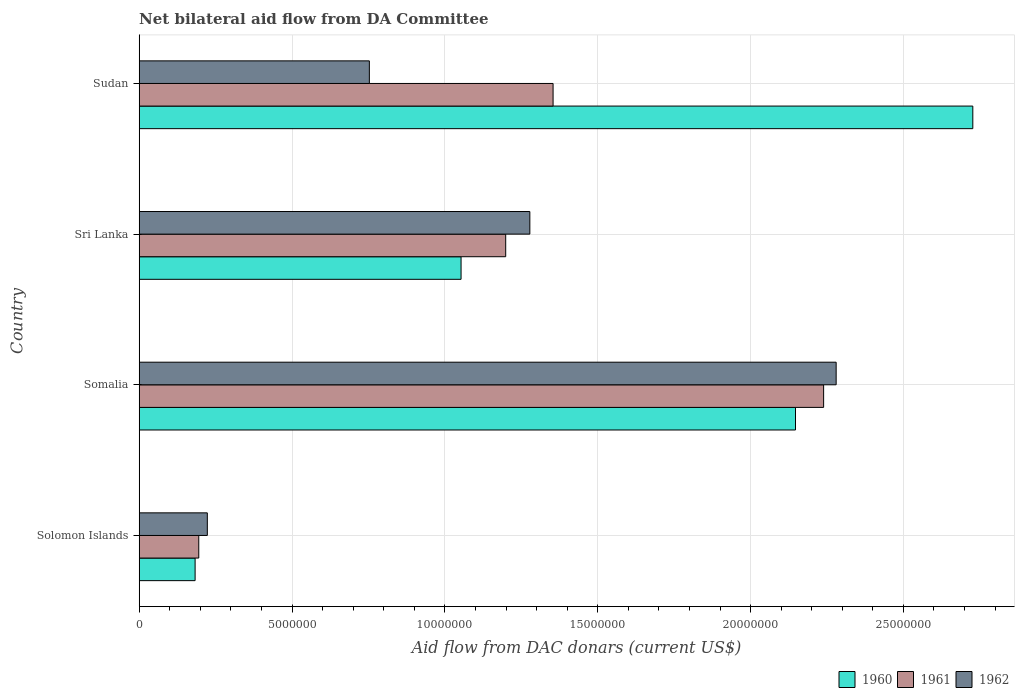Are the number of bars on each tick of the Y-axis equal?
Provide a short and direct response. Yes. How many bars are there on the 4th tick from the bottom?
Your response must be concise. 3. What is the label of the 1st group of bars from the top?
Your answer should be very brief. Sudan. In how many cases, is the number of bars for a given country not equal to the number of legend labels?
Provide a short and direct response. 0. What is the aid flow in in 1962 in Somalia?
Keep it short and to the point. 2.28e+07. Across all countries, what is the maximum aid flow in in 1961?
Provide a short and direct response. 2.24e+07. Across all countries, what is the minimum aid flow in in 1961?
Your answer should be very brief. 1.95e+06. In which country was the aid flow in in 1960 maximum?
Your answer should be very brief. Sudan. In which country was the aid flow in in 1962 minimum?
Make the answer very short. Solomon Islands. What is the total aid flow in in 1960 in the graph?
Ensure brevity in your answer.  6.11e+07. What is the difference between the aid flow in in 1960 in Solomon Islands and that in Sri Lanka?
Keep it short and to the point. -8.70e+06. What is the difference between the aid flow in in 1962 in Solomon Islands and the aid flow in in 1960 in Somalia?
Ensure brevity in your answer.  -1.92e+07. What is the average aid flow in in 1962 per country?
Keep it short and to the point. 1.13e+07. In how many countries, is the aid flow in in 1961 greater than 18000000 US$?
Ensure brevity in your answer.  1. What is the ratio of the aid flow in in 1961 in Solomon Islands to that in Somalia?
Keep it short and to the point. 0.09. Is the aid flow in in 1960 in Solomon Islands less than that in Sudan?
Give a very brief answer. Yes. Is the difference between the aid flow in in 1960 in Somalia and Sri Lanka greater than the difference between the aid flow in in 1961 in Somalia and Sri Lanka?
Your response must be concise. Yes. What is the difference between the highest and the second highest aid flow in in 1960?
Provide a succinct answer. 5.80e+06. What is the difference between the highest and the lowest aid flow in in 1960?
Your answer should be compact. 2.54e+07. Is the sum of the aid flow in in 1962 in Somalia and Sri Lanka greater than the maximum aid flow in in 1960 across all countries?
Offer a terse response. Yes. Are all the bars in the graph horizontal?
Offer a terse response. Yes. How many countries are there in the graph?
Make the answer very short. 4. What is the difference between two consecutive major ticks on the X-axis?
Provide a succinct answer. 5.00e+06. Are the values on the major ticks of X-axis written in scientific E-notation?
Provide a short and direct response. No. Does the graph contain any zero values?
Provide a short and direct response. No. Does the graph contain grids?
Provide a short and direct response. Yes. Where does the legend appear in the graph?
Your answer should be compact. Bottom right. How many legend labels are there?
Make the answer very short. 3. What is the title of the graph?
Give a very brief answer. Net bilateral aid flow from DA Committee. Does "2004" appear as one of the legend labels in the graph?
Give a very brief answer. No. What is the label or title of the X-axis?
Make the answer very short. Aid flow from DAC donars (current US$). What is the label or title of the Y-axis?
Keep it short and to the point. Country. What is the Aid flow from DAC donars (current US$) of 1960 in Solomon Islands?
Your answer should be very brief. 1.83e+06. What is the Aid flow from DAC donars (current US$) of 1961 in Solomon Islands?
Provide a succinct answer. 1.95e+06. What is the Aid flow from DAC donars (current US$) in 1962 in Solomon Islands?
Your answer should be very brief. 2.23e+06. What is the Aid flow from DAC donars (current US$) in 1960 in Somalia?
Your response must be concise. 2.15e+07. What is the Aid flow from DAC donars (current US$) of 1961 in Somalia?
Provide a succinct answer. 2.24e+07. What is the Aid flow from DAC donars (current US$) in 1962 in Somalia?
Offer a terse response. 2.28e+07. What is the Aid flow from DAC donars (current US$) of 1960 in Sri Lanka?
Offer a terse response. 1.05e+07. What is the Aid flow from DAC donars (current US$) of 1961 in Sri Lanka?
Make the answer very short. 1.20e+07. What is the Aid flow from DAC donars (current US$) of 1962 in Sri Lanka?
Your response must be concise. 1.28e+07. What is the Aid flow from DAC donars (current US$) in 1960 in Sudan?
Offer a terse response. 2.73e+07. What is the Aid flow from DAC donars (current US$) of 1961 in Sudan?
Make the answer very short. 1.35e+07. What is the Aid flow from DAC donars (current US$) in 1962 in Sudan?
Your response must be concise. 7.53e+06. Across all countries, what is the maximum Aid flow from DAC donars (current US$) in 1960?
Your answer should be very brief. 2.73e+07. Across all countries, what is the maximum Aid flow from DAC donars (current US$) in 1961?
Give a very brief answer. 2.24e+07. Across all countries, what is the maximum Aid flow from DAC donars (current US$) in 1962?
Your answer should be compact. 2.28e+07. Across all countries, what is the minimum Aid flow from DAC donars (current US$) of 1960?
Your response must be concise. 1.83e+06. Across all countries, what is the minimum Aid flow from DAC donars (current US$) in 1961?
Give a very brief answer. 1.95e+06. Across all countries, what is the minimum Aid flow from DAC donars (current US$) in 1962?
Your response must be concise. 2.23e+06. What is the total Aid flow from DAC donars (current US$) in 1960 in the graph?
Make the answer very short. 6.11e+07. What is the total Aid flow from DAC donars (current US$) in 1961 in the graph?
Ensure brevity in your answer.  4.99e+07. What is the total Aid flow from DAC donars (current US$) of 1962 in the graph?
Give a very brief answer. 4.53e+07. What is the difference between the Aid flow from DAC donars (current US$) of 1960 in Solomon Islands and that in Somalia?
Provide a short and direct response. -1.96e+07. What is the difference between the Aid flow from DAC donars (current US$) in 1961 in Solomon Islands and that in Somalia?
Keep it short and to the point. -2.04e+07. What is the difference between the Aid flow from DAC donars (current US$) in 1962 in Solomon Islands and that in Somalia?
Give a very brief answer. -2.06e+07. What is the difference between the Aid flow from DAC donars (current US$) of 1960 in Solomon Islands and that in Sri Lanka?
Provide a short and direct response. -8.70e+06. What is the difference between the Aid flow from DAC donars (current US$) of 1961 in Solomon Islands and that in Sri Lanka?
Provide a short and direct response. -1.00e+07. What is the difference between the Aid flow from DAC donars (current US$) in 1962 in Solomon Islands and that in Sri Lanka?
Your response must be concise. -1.06e+07. What is the difference between the Aid flow from DAC donars (current US$) of 1960 in Solomon Islands and that in Sudan?
Provide a succinct answer. -2.54e+07. What is the difference between the Aid flow from DAC donars (current US$) in 1961 in Solomon Islands and that in Sudan?
Give a very brief answer. -1.16e+07. What is the difference between the Aid flow from DAC donars (current US$) in 1962 in Solomon Islands and that in Sudan?
Provide a succinct answer. -5.30e+06. What is the difference between the Aid flow from DAC donars (current US$) in 1960 in Somalia and that in Sri Lanka?
Your answer should be compact. 1.09e+07. What is the difference between the Aid flow from DAC donars (current US$) in 1961 in Somalia and that in Sri Lanka?
Give a very brief answer. 1.04e+07. What is the difference between the Aid flow from DAC donars (current US$) in 1962 in Somalia and that in Sri Lanka?
Keep it short and to the point. 1.00e+07. What is the difference between the Aid flow from DAC donars (current US$) of 1960 in Somalia and that in Sudan?
Offer a very short reply. -5.80e+06. What is the difference between the Aid flow from DAC donars (current US$) in 1961 in Somalia and that in Sudan?
Give a very brief answer. 8.85e+06. What is the difference between the Aid flow from DAC donars (current US$) in 1962 in Somalia and that in Sudan?
Make the answer very short. 1.53e+07. What is the difference between the Aid flow from DAC donars (current US$) in 1960 in Sri Lanka and that in Sudan?
Your response must be concise. -1.67e+07. What is the difference between the Aid flow from DAC donars (current US$) of 1961 in Sri Lanka and that in Sudan?
Your answer should be compact. -1.55e+06. What is the difference between the Aid flow from DAC donars (current US$) in 1962 in Sri Lanka and that in Sudan?
Give a very brief answer. 5.25e+06. What is the difference between the Aid flow from DAC donars (current US$) of 1960 in Solomon Islands and the Aid flow from DAC donars (current US$) of 1961 in Somalia?
Ensure brevity in your answer.  -2.06e+07. What is the difference between the Aid flow from DAC donars (current US$) of 1960 in Solomon Islands and the Aid flow from DAC donars (current US$) of 1962 in Somalia?
Your response must be concise. -2.10e+07. What is the difference between the Aid flow from DAC donars (current US$) of 1961 in Solomon Islands and the Aid flow from DAC donars (current US$) of 1962 in Somalia?
Your answer should be very brief. -2.08e+07. What is the difference between the Aid flow from DAC donars (current US$) of 1960 in Solomon Islands and the Aid flow from DAC donars (current US$) of 1961 in Sri Lanka?
Your response must be concise. -1.02e+07. What is the difference between the Aid flow from DAC donars (current US$) of 1960 in Solomon Islands and the Aid flow from DAC donars (current US$) of 1962 in Sri Lanka?
Your answer should be very brief. -1.10e+07. What is the difference between the Aid flow from DAC donars (current US$) of 1961 in Solomon Islands and the Aid flow from DAC donars (current US$) of 1962 in Sri Lanka?
Provide a short and direct response. -1.08e+07. What is the difference between the Aid flow from DAC donars (current US$) in 1960 in Solomon Islands and the Aid flow from DAC donars (current US$) in 1961 in Sudan?
Offer a very short reply. -1.17e+07. What is the difference between the Aid flow from DAC donars (current US$) in 1960 in Solomon Islands and the Aid flow from DAC donars (current US$) in 1962 in Sudan?
Provide a succinct answer. -5.70e+06. What is the difference between the Aid flow from DAC donars (current US$) in 1961 in Solomon Islands and the Aid flow from DAC donars (current US$) in 1962 in Sudan?
Offer a very short reply. -5.58e+06. What is the difference between the Aid flow from DAC donars (current US$) in 1960 in Somalia and the Aid flow from DAC donars (current US$) in 1961 in Sri Lanka?
Offer a terse response. 9.48e+06. What is the difference between the Aid flow from DAC donars (current US$) in 1960 in Somalia and the Aid flow from DAC donars (current US$) in 1962 in Sri Lanka?
Give a very brief answer. 8.69e+06. What is the difference between the Aid flow from DAC donars (current US$) of 1961 in Somalia and the Aid flow from DAC donars (current US$) of 1962 in Sri Lanka?
Ensure brevity in your answer.  9.61e+06. What is the difference between the Aid flow from DAC donars (current US$) in 1960 in Somalia and the Aid flow from DAC donars (current US$) in 1961 in Sudan?
Make the answer very short. 7.93e+06. What is the difference between the Aid flow from DAC donars (current US$) in 1960 in Somalia and the Aid flow from DAC donars (current US$) in 1962 in Sudan?
Keep it short and to the point. 1.39e+07. What is the difference between the Aid flow from DAC donars (current US$) of 1961 in Somalia and the Aid flow from DAC donars (current US$) of 1962 in Sudan?
Make the answer very short. 1.49e+07. What is the difference between the Aid flow from DAC donars (current US$) of 1960 in Sri Lanka and the Aid flow from DAC donars (current US$) of 1961 in Sudan?
Your response must be concise. -3.01e+06. What is the difference between the Aid flow from DAC donars (current US$) in 1961 in Sri Lanka and the Aid flow from DAC donars (current US$) in 1962 in Sudan?
Give a very brief answer. 4.46e+06. What is the average Aid flow from DAC donars (current US$) of 1960 per country?
Keep it short and to the point. 1.53e+07. What is the average Aid flow from DAC donars (current US$) of 1961 per country?
Provide a succinct answer. 1.25e+07. What is the average Aid flow from DAC donars (current US$) in 1962 per country?
Make the answer very short. 1.13e+07. What is the difference between the Aid flow from DAC donars (current US$) in 1960 and Aid flow from DAC donars (current US$) in 1961 in Solomon Islands?
Keep it short and to the point. -1.20e+05. What is the difference between the Aid flow from DAC donars (current US$) of 1960 and Aid flow from DAC donars (current US$) of 1962 in Solomon Islands?
Ensure brevity in your answer.  -4.00e+05. What is the difference between the Aid flow from DAC donars (current US$) in 1961 and Aid flow from DAC donars (current US$) in 1962 in Solomon Islands?
Your answer should be very brief. -2.80e+05. What is the difference between the Aid flow from DAC donars (current US$) of 1960 and Aid flow from DAC donars (current US$) of 1961 in Somalia?
Your response must be concise. -9.20e+05. What is the difference between the Aid flow from DAC donars (current US$) in 1960 and Aid flow from DAC donars (current US$) in 1962 in Somalia?
Provide a succinct answer. -1.33e+06. What is the difference between the Aid flow from DAC donars (current US$) in 1961 and Aid flow from DAC donars (current US$) in 1962 in Somalia?
Your answer should be compact. -4.10e+05. What is the difference between the Aid flow from DAC donars (current US$) of 1960 and Aid flow from DAC donars (current US$) of 1961 in Sri Lanka?
Give a very brief answer. -1.46e+06. What is the difference between the Aid flow from DAC donars (current US$) in 1960 and Aid flow from DAC donars (current US$) in 1962 in Sri Lanka?
Give a very brief answer. -2.25e+06. What is the difference between the Aid flow from DAC donars (current US$) of 1961 and Aid flow from DAC donars (current US$) of 1962 in Sri Lanka?
Provide a short and direct response. -7.90e+05. What is the difference between the Aid flow from DAC donars (current US$) of 1960 and Aid flow from DAC donars (current US$) of 1961 in Sudan?
Offer a very short reply. 1.37e+07. What is the difference between the Aid flow from DAC donars (current US$) in 1960 and Aid flow from DAC donars (current US$) in 1962 in Sudan?
Keep it short and to the point. 1.97e+07. What is the difference between the Aid flow from DAC donars (current US$) in 1961 and Aid flow from DAC donars (current US$) in 1962 in Sudan?
Make the answer very short. 6.01e+06. What is the ratio of the Aid flow from DAC donars (current US$) of 1960 in Solomon Islands to that in Somalia?
Keep it short and to the point. 0.09. What is the ratio of the Aid flow from DAC donars (current US$) of 1961 in Solomon Islands to that in Somalia?
Provide a succinct answer. 0.09. What is the ratio of the Aid flow from DAC donars (current US$) in 1962 in Solomon Islands to that in Somalia?
Your answer should be very brief. 0.1. What is the ratio of the Aid flow from DAC donars (current US$) in 1960 in Solomon Islands to that in Sri Lanka?
Make the answer very short. 0.17. What is the ratio of the Aid flow from DAC donars (current US$) in 1961 in Solomon Islands to that in Sri Lanka?
Your answer should be compact. 0.16. What is the ratio of the Aid flow from DAC donars (current US$) in 1962 in Solomon Islands to that in Sri Lanka?
Keep it short and to the point. 0.17. What is the ratio of the Aid flow from DAC donars (current US$) of 1960 in Solomon Islands to that in Sudan?
Offer a terse response. 0.07. What is the ratio of the Aid flow from DAC donars (current US$) of 1961 in Solomon Islands to that in Sudan?
Provide a succinct answer. 0.14. What is the ratio of the Aid flow from DAC donars (current US$) of 1962 in Solomon Islands to that in Sudan?
Keep it short and to the point. 0.3. What is the ratio of the Aid flow from DAC donars (current US$) in 1960 in Somalia to that in Sri Lanka?
Keep it short and to the point. 2.04. What is the ratio of the Aid flow from DAC donars (current US$) of 1961 in Somalia to that in Sri Lanka?
Offer a terse response. 1.87. What is the ratio of the Aid flow from DAC donars (current US$) in 1962 in Somalia to that in Sri Lanka?
Your answer should be very brief. 1.78. What is the ratio of the Aid flow from DAC donars (current US$) of 1960 in Somalia to that in Sudan?
Provide a succinct answer. 0.79. What is the ratio of the Aid flow from DAC donars (current US$) of 1961 in Somalia to that in Sudan?
Keep it short and to the point. 1.65. What is the ratio of the Aid flow from DAC donars (current US$) in 1962 in Somalia to that in Sudan?
Give a very brief answer. 3.03. What is the ratio of the Aid flow from DAC donars (current US$) of 1960 in Sri Lanka to that in Sudan?
Provide a short and direct response. 0.39. What is the ratio of the Aid flow from DAC donars (current US$) in 1961 in Sri Lanka to that in Sudan?
Your response must be concise. 0.89. What is the ratio of the Aid flow from DAC donars (current US$) in 1962 in Sri Lanka to that in Sudan?
Provide a short and direct response. 1.7. What is the difference between the highest and the second highest Aid flow from DAC donars (current US$) of 1960?
Provide a short and direct response. 5.80e+06. What is the difference between the highest and the second highest Aid flow from DAC donars (current US$) of 1961?
Make the answer very short. 8.85e+06. What is the difference between the highest and the second highest Aid flow from DAC donars (current US$) in 1962?
Give a very brief answer. 1.00e+07. What is the difference between the highest and the lowest Aid flow from DAC donars (current US$) in 1960?
Your answer should be very brief. 2.54e+07. What is the difference between the highest and the lowest Aid flow from DAC donars (current US$) in 1961?
Give a very brief answer. 2.04e+07. What is the difference between the highest and the lowest Aid flow from DAC donars (current US$) of 1962?
Ensure brevity in your answer.  2.06e+07. 